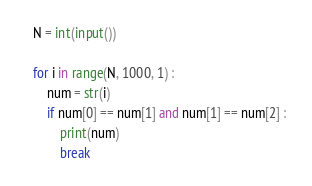<code> <loc_0><loc_0><loc_500><loc_500><_Python_>N = int(input())

for i in range(N, 1000, 1) : 
    num = str(i)
    if num[0] == num[1] and num[1] == num[2] : 
        print(num)
        break</code> 